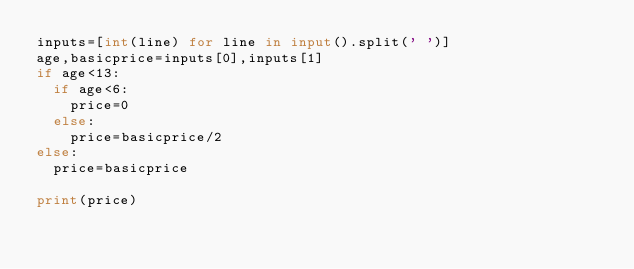<code> <loc_0><loc_0><loc_500><loc_500><_Python_>inputs=[int(line) for line in input().split(' ')]
age,basicprice=inputs[0],inputs[1]
if age<13:
  if age<6:
    price=0
  else:
  	price=basicprice/2
else:
  price=basicprice
  
print(price)</code> 